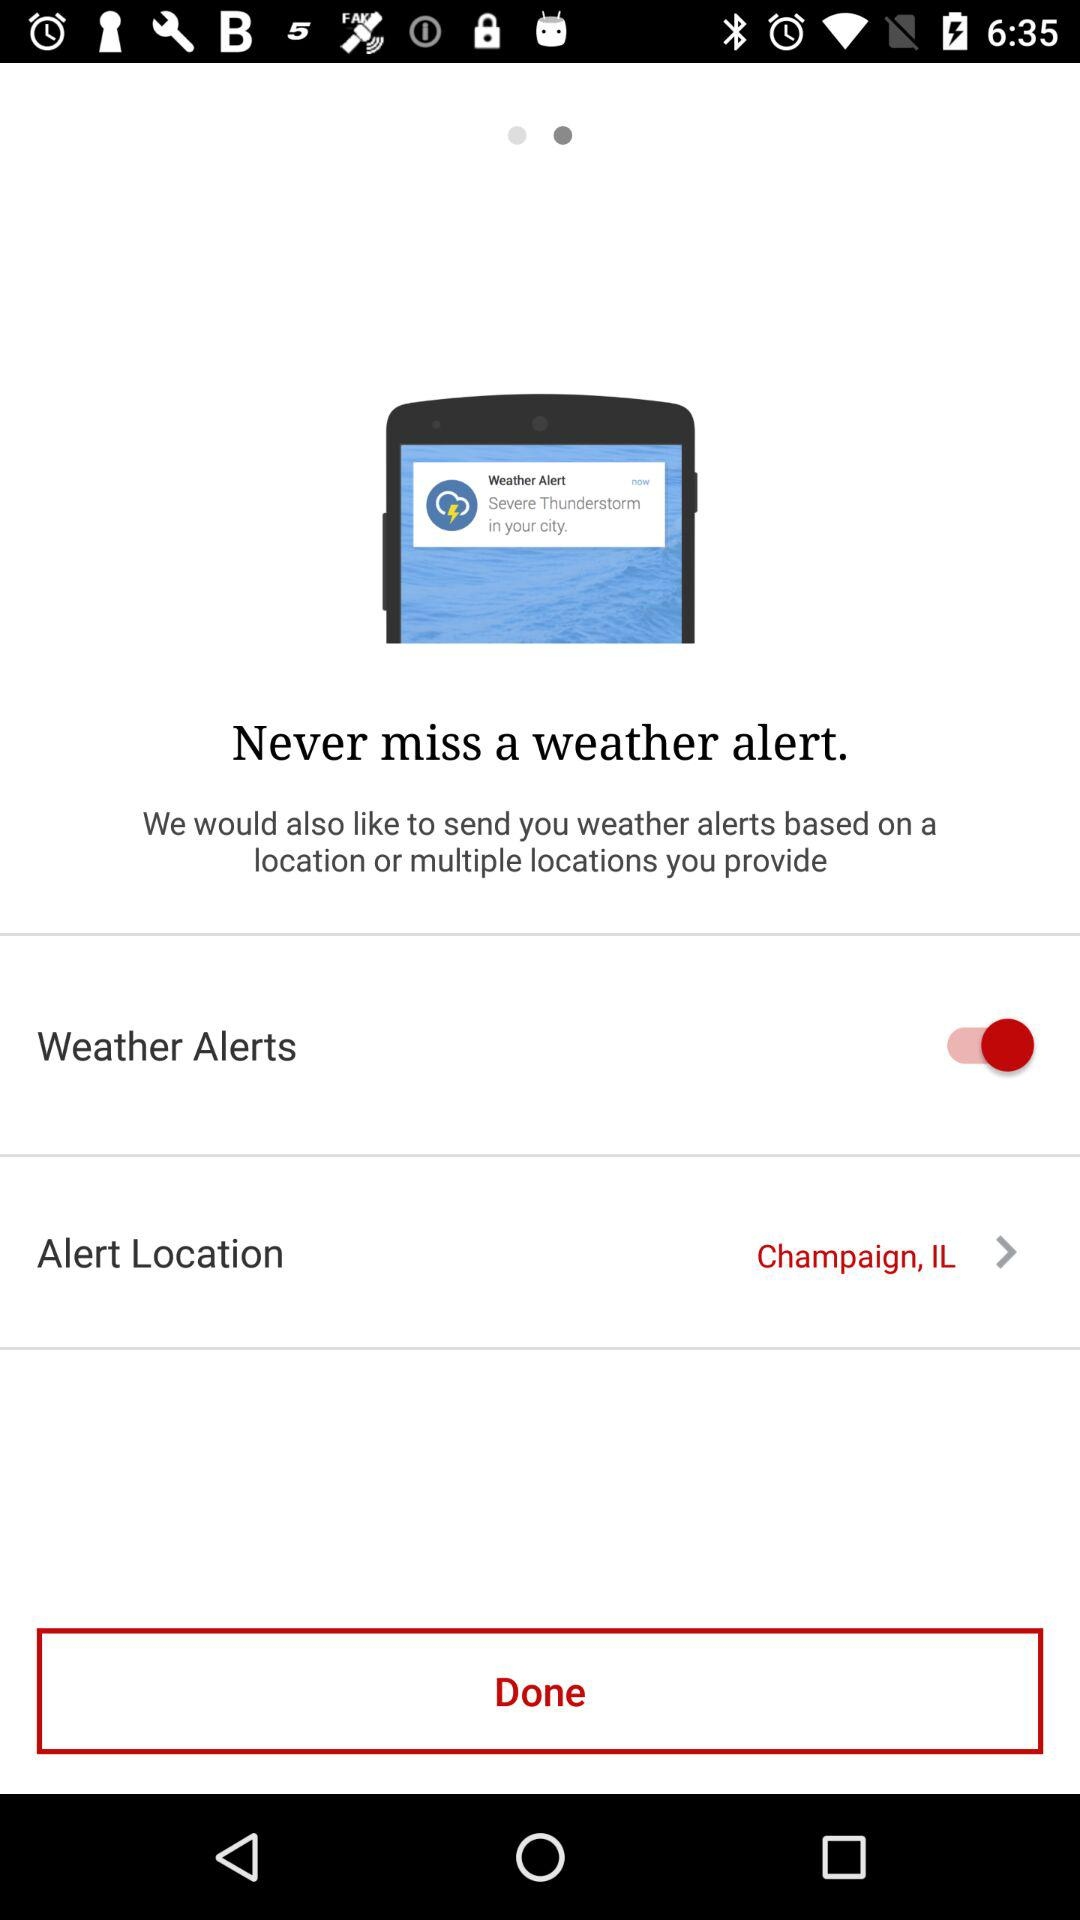What is the location? The location is Champaign, IL. 